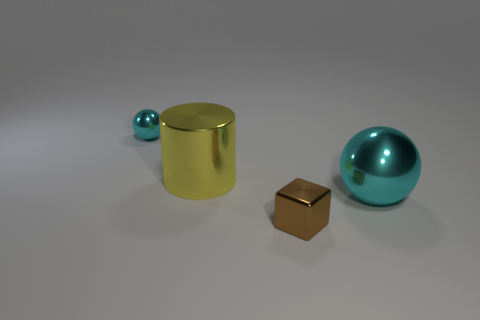Add 2 cubes. How many objects exist? 6 Subtract all blocks. How many objects are left? 3 Subtract all small objects. Subtract all yellow objects. How many objects are left? 1 Add 2 large things. How many large things are left? 4 Add 1 small green matte spheres. How many small green matte spheres exist? 1 Subtract 0 blue cylinders. How many objects are left? 4 